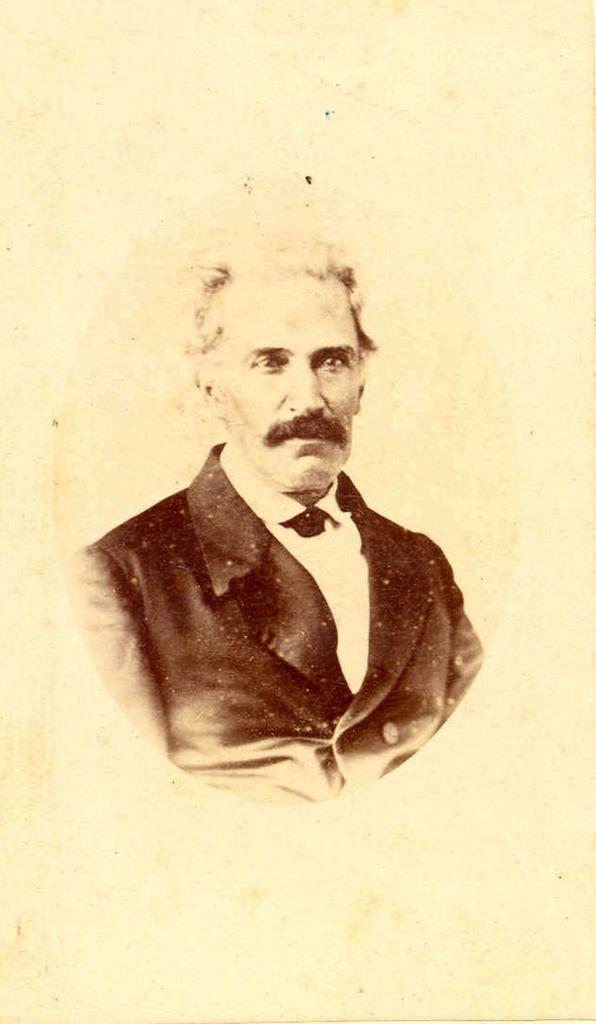In one or two sentences, can you explain what this image depicts? In this image we can see painting of a human being who is wearing black color suit. 